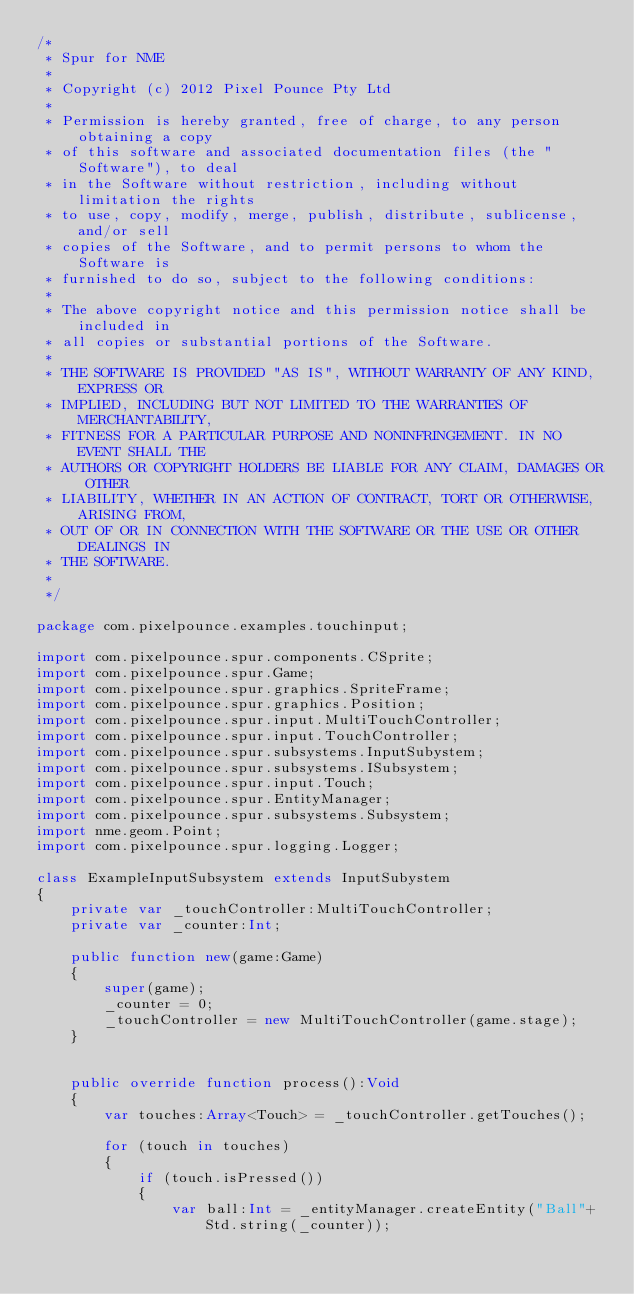<code> <loc_0><loc_0><loc_500><loc_500><_Haxe_>/*
 * Spur for NME
 *
 * Copyright (c) 2012 Pixel Pounce Pty Ltd
 *
 * Permission is hereby granted, free of charge, to any person obtaining a copy
 * of this software and associated documentation files (the "Software"), to deal
 * in the Software without restriction, including without limitation the rights
 * to use, copy, modify, merge, publish, distribute, sublicense, and/or sell
 * copies of the Software, and to permit persons to whom the Software is
 * furnished to do so, subject to the following conditions:
 *
 * The above copyright notice and this permission notice shall be included in
 * all copies or substantial portions of the Software.
 *
 * THE SOFTWARE IS PROVIDED "AS IS", WITHOUT WARRANTY OF ANY KIND, EXPRESS OR
 * IMPLIED, INCLUDING BUT NOT LIMITED TO THE WARRANTIES OF MERCHANTABILITY,
 * FITNESS FOR A PARTICULAR PURPOSE AND NONINFRINGEMENT. IN NO EVENT SHALL THE
 * AUTHORS OR COPYRIGHT HOLDERS BE LIABLE FOR ANY CLAIM, DAMAGES OR OTHER
 * LIABILITY, WHETHER IN AN ACTION OF CONTRACT, TORT OR OTHERWISE, ARISING FROM,
 * OUT OF OR IN CONNECTION WITH THE SOFTWARE OR THE USE OR OTHER DEALINGS IN
 * THE SOFTWARE.
 * 
 */

package com.pixelpounce.examples.touchinput;

import com.pixelpounce.spur.components.CSprite;
import com.pixelpounce.spur.Game;
import com.pixelpounce.spur.graphics.SpriteFrame;
import com.pixelpounce.spur.graphics.Position;
import com.pixelpounce.spur.input.MultiTouchController;
import com.pixelpounce.spur.input.TouchController;
import com.pixelpounce.spur.subsystems.InputSubystem;
import com.pixelpounce.spur.subsystems.ISubsystem;
import com.pixelpounce.spur.input.Touch;
import com.pixelpounce.spur.EntityManager;
import com.pixelpounce.spur.subsystems.Subsystem;
import nme.geom.Point;
import com.pixelpounce.spur.logging.Logger;

class ExampleInputSubsystem extends InputSubystem
{
	private var _touchController:MultiTouchController;
	private var _counter:Int;
	
	public function new(game:Game) 
	{
		super(game);
		_counter = 0;
		_touchController = new MultiTouchController(game.stage);
	}
	
	
	public override function process():Void 
	{
		var touches:Array<Touch> = _touchController.getTouches();
		
		for (touch in touches)
		{
			if (touch.isPressed())
			{
				var ball:Int = _entityManager.createEntity("Ball"+Std.string(_counter));</code> 